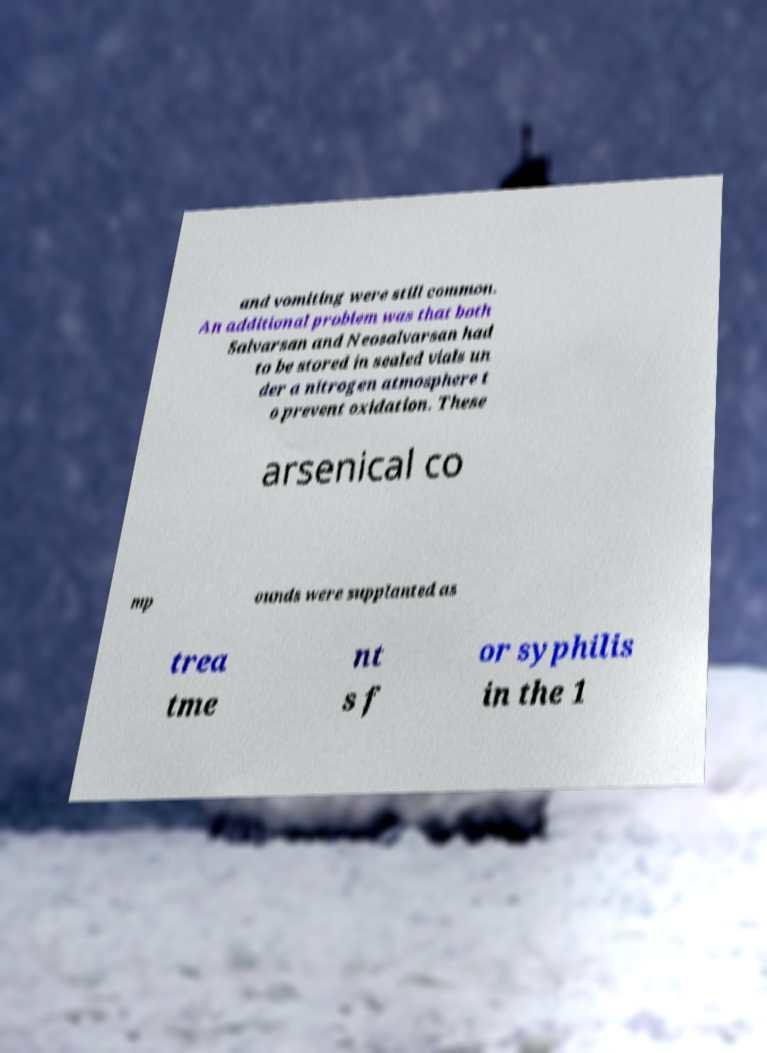Can you read and provide the text displayed in the image?This photo seems to have some interesting text. Can you extract and type it out for me? and vomiting were still common. An additional problem was that both Salvarsan and Neosalvarsan had to be stored in sealed vials un der a nitrogen atmosphere t o prevent oxidation. These arsenical co mp ounds were supplanted as trea tme nt s f or syphilis in the 1 